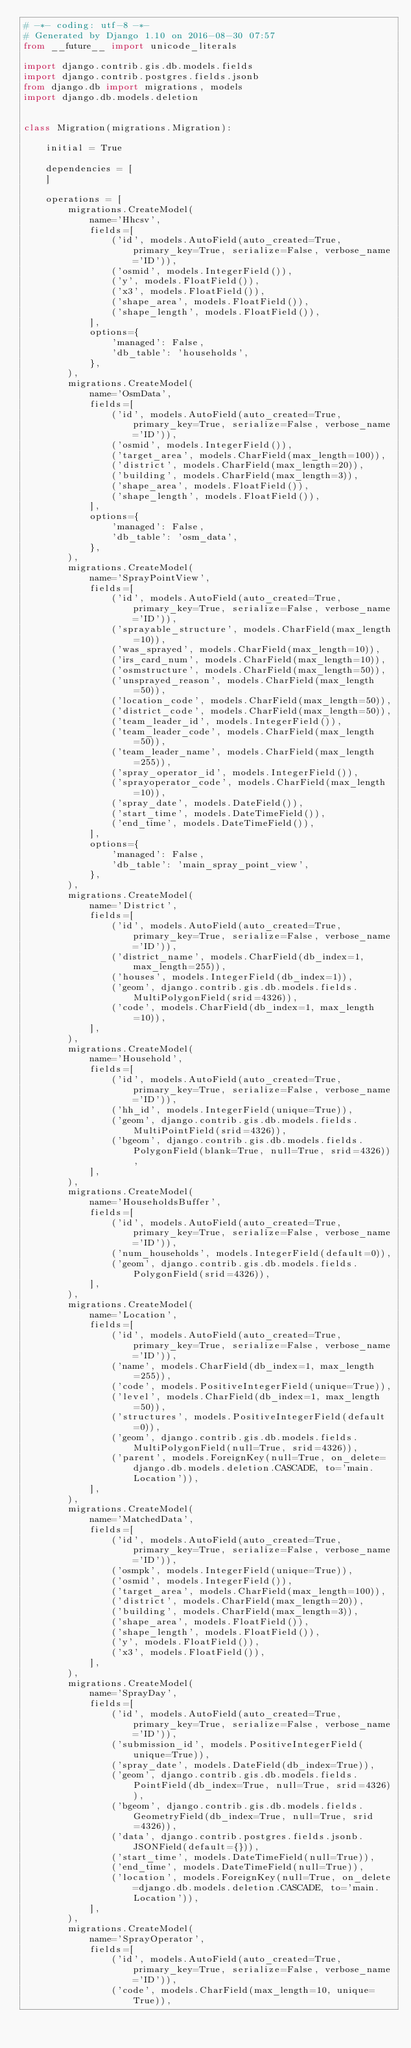Convert code to text. <code><loc_0><loc_0><loc_500><loc_500><_Python_># -*- coding: utf-8 -*-
# Generated by Django 1.10 on 2016-08-30 07:57
from __future__ import unicode_literals

import django.contrib.gis.db.models.fields
import django.contrib.postgres.fields.jsonb
from django.db import migrations, models
import django.db.models.deletion


class Migration(migrations.Migration):

    initial = True

    dependencies = [
    ]

    operations = [
        migrations.CreateModel(
            name='Hhcsv',
            fields=[
                ('id', models.AutoField(auto_created=True, primary_key=True, serialize=False, verbose_name='ID')),
                ('osmid', models.IntegerField()),
                ('y', models.FloatField()),
                ('x3', models.FloatField()),
                ('shape_area', models.FloatField()),
                ('shape_length', models.FloatField()),
            ],
            options={
                'managed': False,
                'db_table': 'households',
            },
        ),
        migrations.CreateModel(
            name='OsmData',
            fields=[
                ('id', models.AutoField(auto_created=True, primary_key=True, serialize=False, verbose_name='ID')),
                ('osmid', models.IntegerField()),
                ('target_area', models.CharField(max_length=100)),
                ('district', models.CharField(max_length=20)),
                ('building', models.CharField(max_length=3)),
                ('shape_area', models.FloatField()),
                ('shape_length', models.FloatField()),
            ],
            options={
                'managed': False,
                'db_table': 'osm_data',
            },
        ),
        migrations.CreateModel(
            name='SprayPointView',
            fields=[
                ('id', models.AutoField(auto_created=True, primary_key=True, serialize=False, verbose_name='ID')),
                ('sprayable_structure', models.CharField(max_length=10)),
                ('was_sprayed', models.CharField(max_length=10)),
                ('irs_card_num', models.CharField(max_length=10)),
                ('osmstructure', models.CharField(max_length=50)),
                ('unsprayed_reason', models.CharField(max_length=50)),
                ('location_code', models.CharField(max_length=50)),
                ('district_code', models.CharField(max_length=50)),
                ('team_leader_id', models.IntegerField()),
                ('team_leader_code', models.CharField(max_length=50)),
                ('team_leader_name', models.CharField(max_length=255)),
                ('spray_operator_id', models.IntegerField()),
                ('sprayoperator_code', models.CharField(max_length=10)),
                ('spray_date', models.DateField()),
                ('start_time', models.DateTimeField()),
                ('end_time', models.DateTimeField()),
            ],
            options={
                'managed': False,
                'db_table': 'main_spray_point_view',
            },
        ),
        migrations.CreateModel(
            name='District',
            fields=[
                ('id', models.AutoField(auto_created=True, primary_key=True, serialize=False, verbose_name='ID')),
                ('district_name', models.CharField(db_index=1, max_length=255)),
                ('houses', models.IntegerField(db_index=1)),
                ('geom', django.contrib.gis.db.models.fields.MultiPolygonField(srid=4326)),
                ('code', models.CharField(db_index=1, max_length=10)),
            ],
        ),
        migrations.CreateModel(
            name='Household',
            fields=[
                ('id', models.AutoField(auto_created=True, primary_key=True, serialize=False, verbose_name='ID')),
                ('hh_id', models.IntegerField(unique=True)),
                ('geom', django.contrib.gis.db.models.fields.MultiPointField(srid=4326)),
                ('bgeom', django.contrib.gis.db.models.fields.PolygonField(blank=True, null=True, srid=4326)),
            ],
        ),
        migrations.CreateModel(
            name='HouseholdsBuffer',
            fields=[
                ('id', models.AutoField(auto_created=True, primary_key=True, serialize=False, verbose_name='ID')),
                ('num_households', models.IntegerField(default=0)),
                ('geom', django.contrib.gis.db.models.fields.PolygonField(srid=4326)),
            ],
        ),
        migrations.CreateModel(
            name='Location',
            fields=[
                ('id', models.AutoField(auto_created=True, primary_key=True, serialize=False, verbose_name='ID')),
                ('name', models.CharField(db_index=1, max_length=255)),
                ('code', models.PositiveIntegerField(unique=True)),
                ('level', models.CharField(db_index=1, max_length=50)),
                ('structures', models.PositiveIntegerField(default=0)),
                ('geom', django.contrib.gis.db.models.fields.MultiPolygonField(null=True, srid=4326)),
                ('parent', models.ForeignKey(null=True, on_delete=django.db.models.deletion.CASCADE, to='main.Location')),
            ],
        ),
        migrations.CreateModel(
            name='MatchedData',
            fields=[
                ('id', models.AutoField(auto_created=True, primary_key=True, serialize=False, verbose_name='ID')),
                ('osmpk', models.IntegerField(unique=True)),
                ('osmid', models.IntegerField()),
                ('target_area', models.CharField(max_length=100)),
                ('district', models.CharField(max_length=20)),
                ('building', models.CharField(max_length=3)),
                ('shape_area', models.FloatField()),
                ('shape_length', models.FloatField()),
                ('y', models.FloatField()),
                ('x3', models.FloatField()),
            ],
        ),
        migrations.CreateModel(
            name='SprayDay',
            fields=[
                ('id', models.AutoField(auto_created=True, primary_key=True, serialize=False, verbose_name='ID')),
                ('submission_id', models.PositiveIntegerField(unique=True)),
                ('spray_date', models.DateField(db_index=True)),
                ('geom', django.contrib.gis.db.models.fields.PointField(db_index=True, null=True, srid=4326)),
                ('bgeom', django.contrib.gis.db.models.fields.GeometryField(db_index=True, null=True, srid=4326)),
                ('data', django.contrib.postgres.fields.jsonb.JSONField(default={})),
                ('start_time', models.DateTimeField(null=True)),
                ('end_time', models.DateTimeField(null=True)),
                ('location', models.ForeignKey(null=True, on_delete=django.db.models.deletion.CASCADE, to='main.Location')),
            ],
        ),
        migrations.CreateModel(
            name='SprayOperator',
            fields=[
                ('id', models.AutoField(auto_created=True, primary_key=True, serialize=False, verbose_name='ID')),
                ('code', models.CharField(max_length=10, unique=True)),</code> 